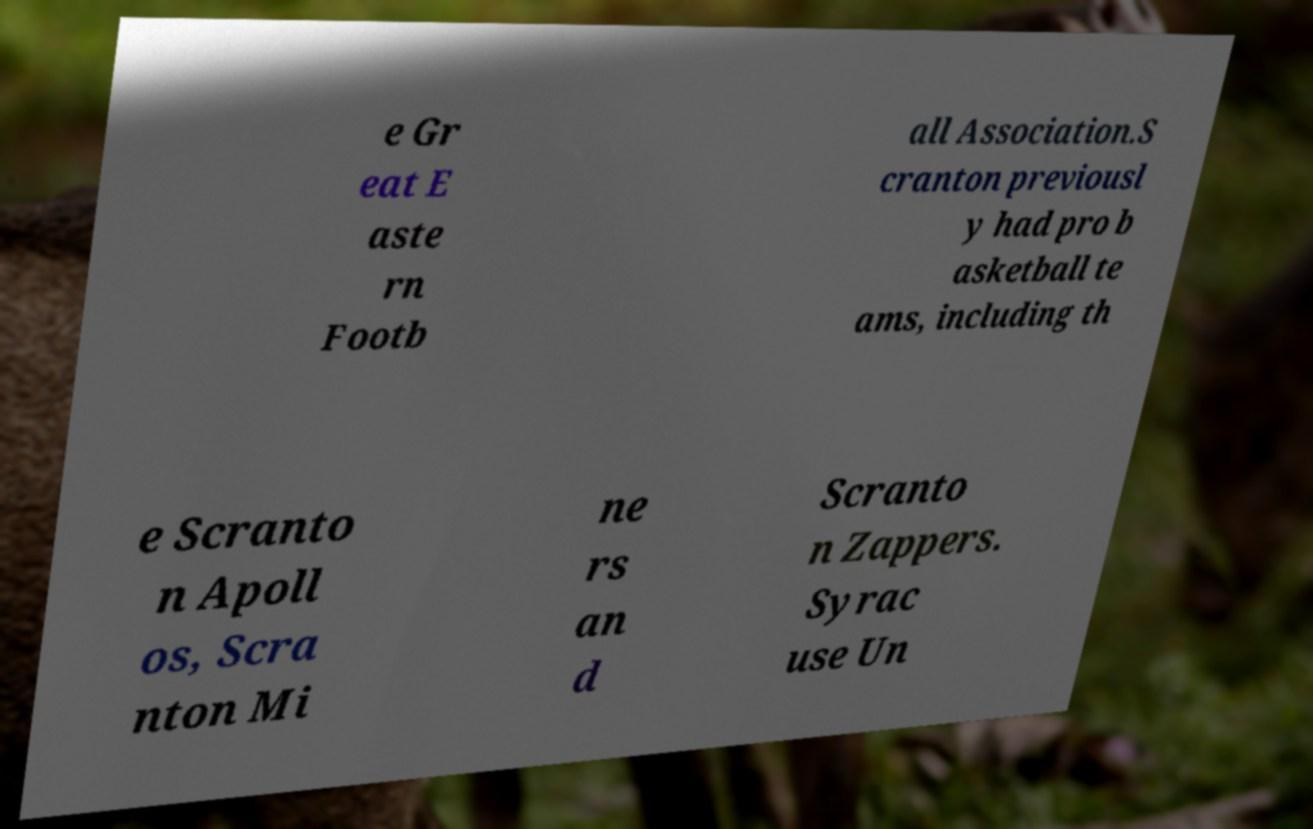Could you extract and type out the text from this image? e Gr eat E aste rn Footb all Association.S cranton previousl y had pro b asketball te ams, including th e Scranto n Apoll os, Scra nton Mi ne rs an d Scranto n Zappers. Syrac use Un 